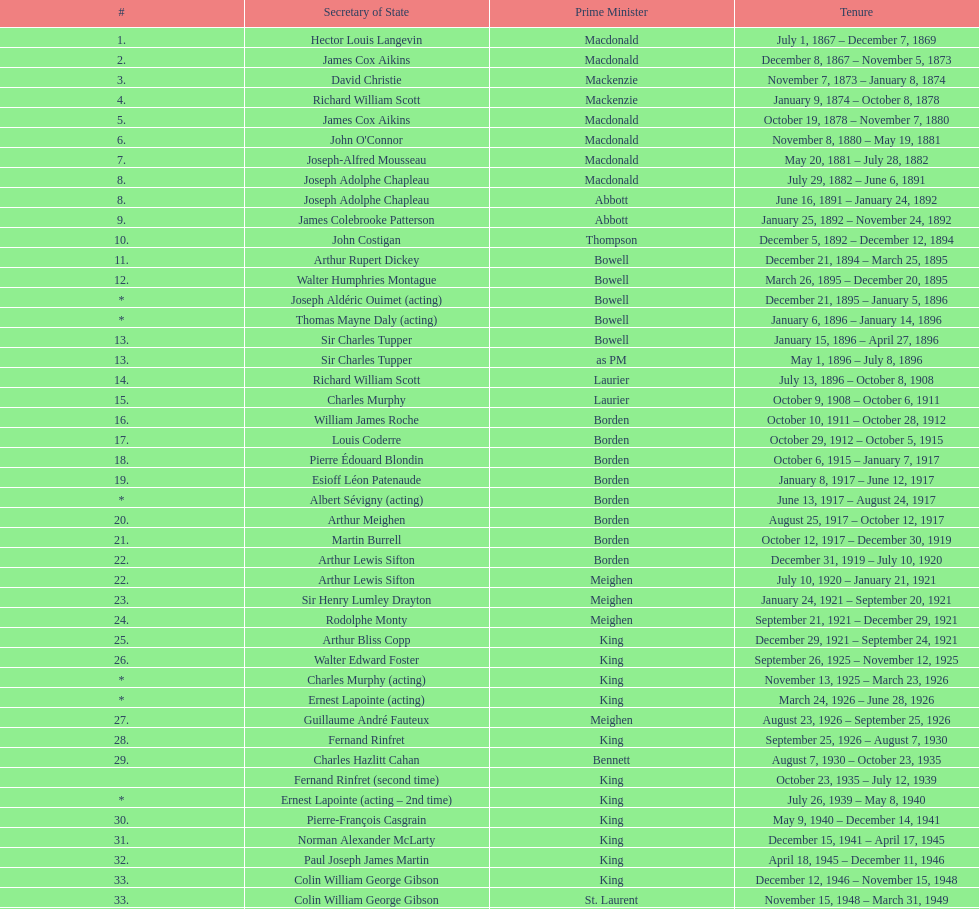Did macdonald hold the position of prime minister preceding or succeeding bowell? Before. 